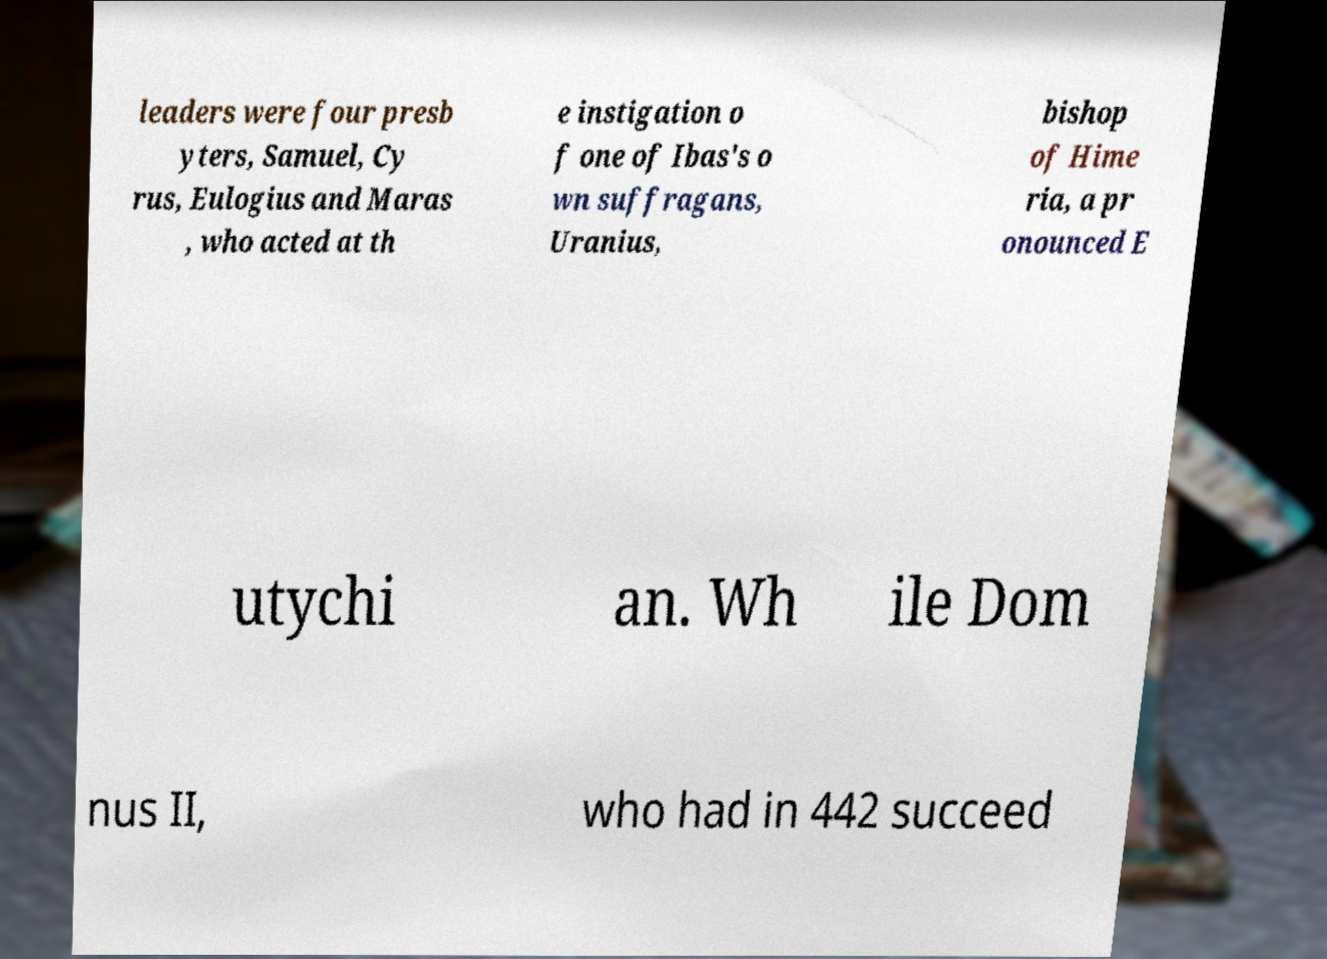For documentation purposes, I need the text within this image transcribed. Could you provide that? leaders were four presb yters, Samuel, Cy rus, Eulogius and Maras , who acted at th e instigation o f one of Ibas's o wn suffragans, Uranius, bishop of Hime ria, a pr onounced E utychi an. Wh ile Dom nus II, who had in 442 succeed 